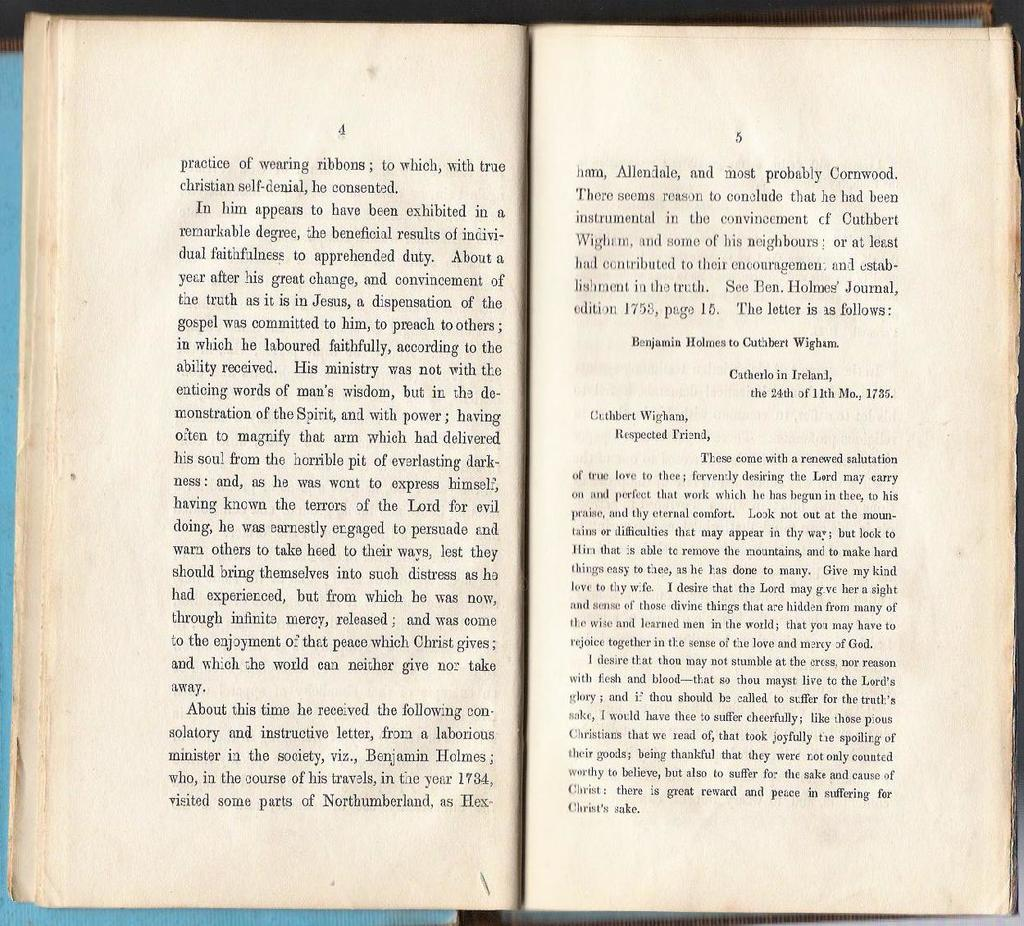<image>
Present a compact description of the photo's key features. A book is open to pages 4 and 5. 